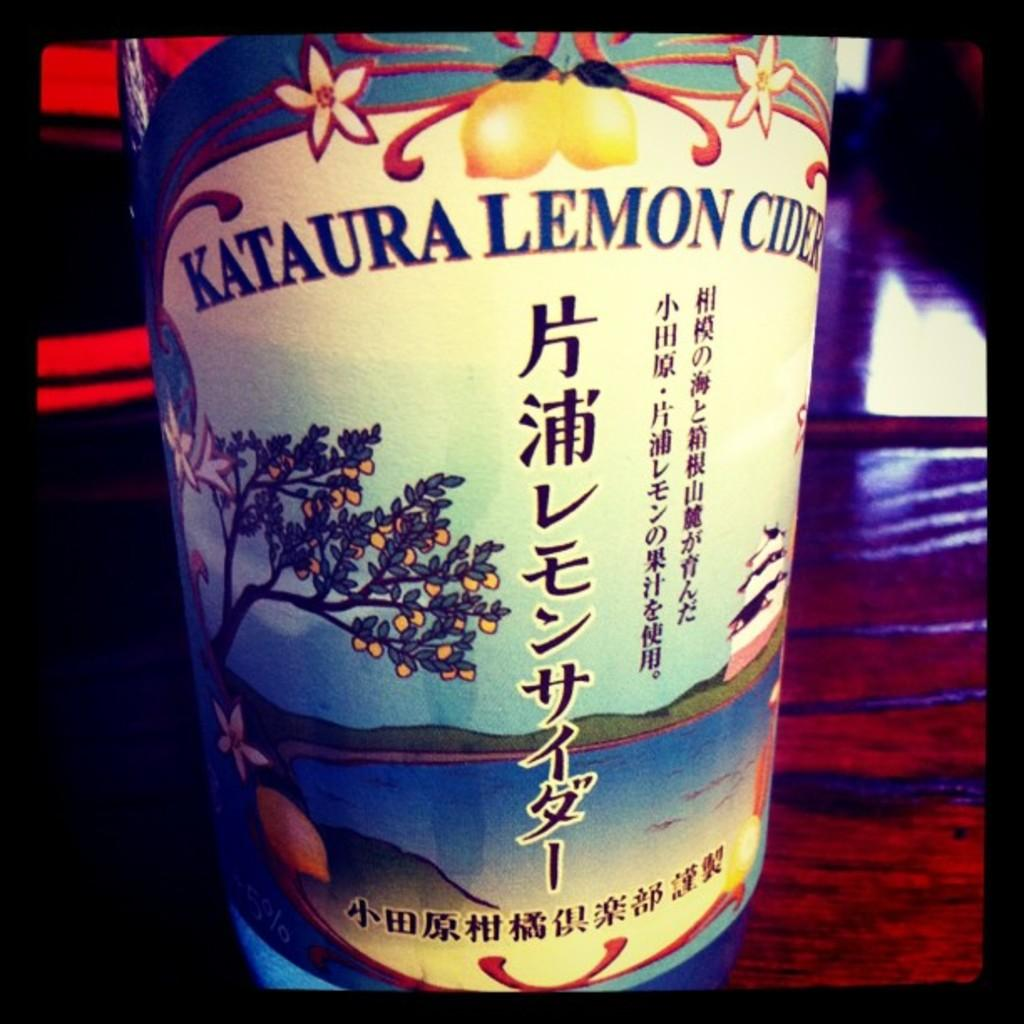What type of object might the image represent? The image might be a photo frame. What is present in the image besides the photo frame? There is a table in the image. What is on the table in the image? There is a bottle on the table. What is unique about the bottle? The bottle has pictures on it and text written on it. What type of songs can be heard coming from the roof in the image? There is no roof or any indication of music in the image, so it's not possible to determine what songs might be heard. 